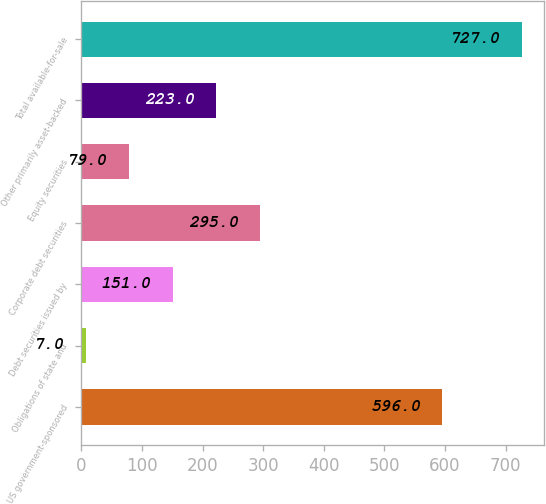Convert chart to OTSL. <chart><loc_0><loc_0><loc_500><loc_500><bar_chart><fcel>US government-sponsored<fcel>Obligations of state and<fcel>Debt securities issued by<fcel>Corporate debt securities<fcel>Equity securities<fcel>Other primarily asset-backed<fcel>Total available-for-sale<nl><fcel>596<fcel>7<fcel>151<fcel>295<fcel>79<fcel>223<fcel>727<nl></chart> 